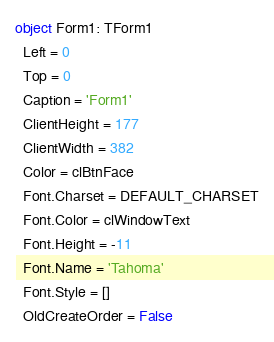<code> <loc_0><loc_0><loc_500><loc_500><_Pascal_>object Form1: TForm1
  Left = 0
  Top = 0
  Caption = 'Form1'
  ClientHeight = 177
  ClientWidth = 382
  Color = clBtnFace
  Font.Charset = DEFAULT_CHARSET
  Font.Color = clWindowText
  Font.Height = -11
  Font.Name = 'Tahoma'
  Font.Style = []
  OldCreateOrder = False</code> 